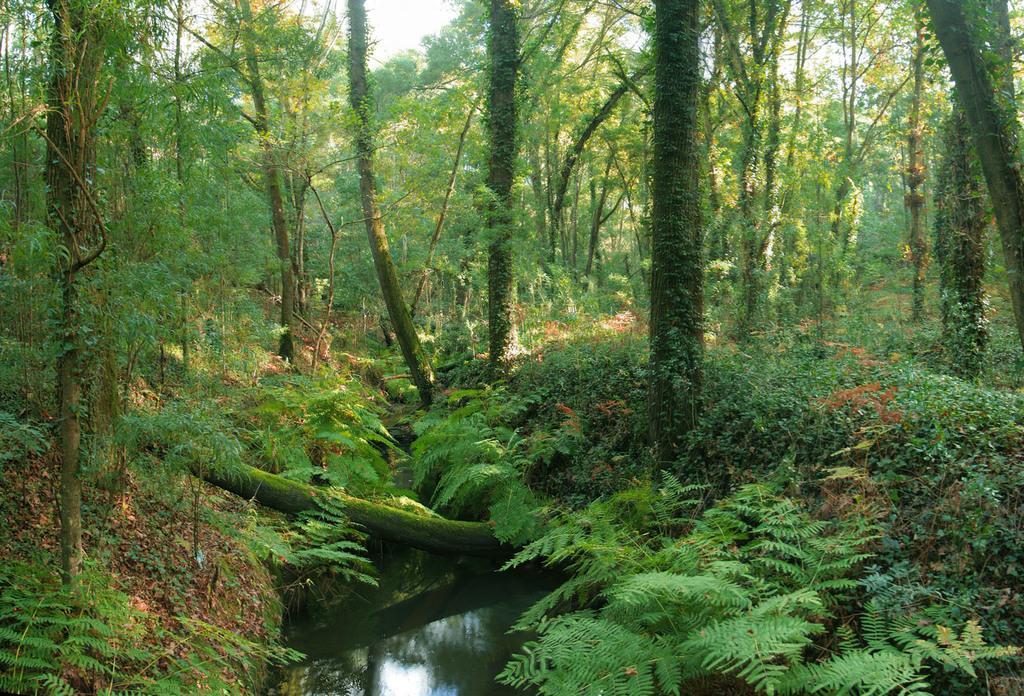In one or two sentences, can you explain what this image depicts? In this picture we can see some water, around we can see full of plants and trees. 